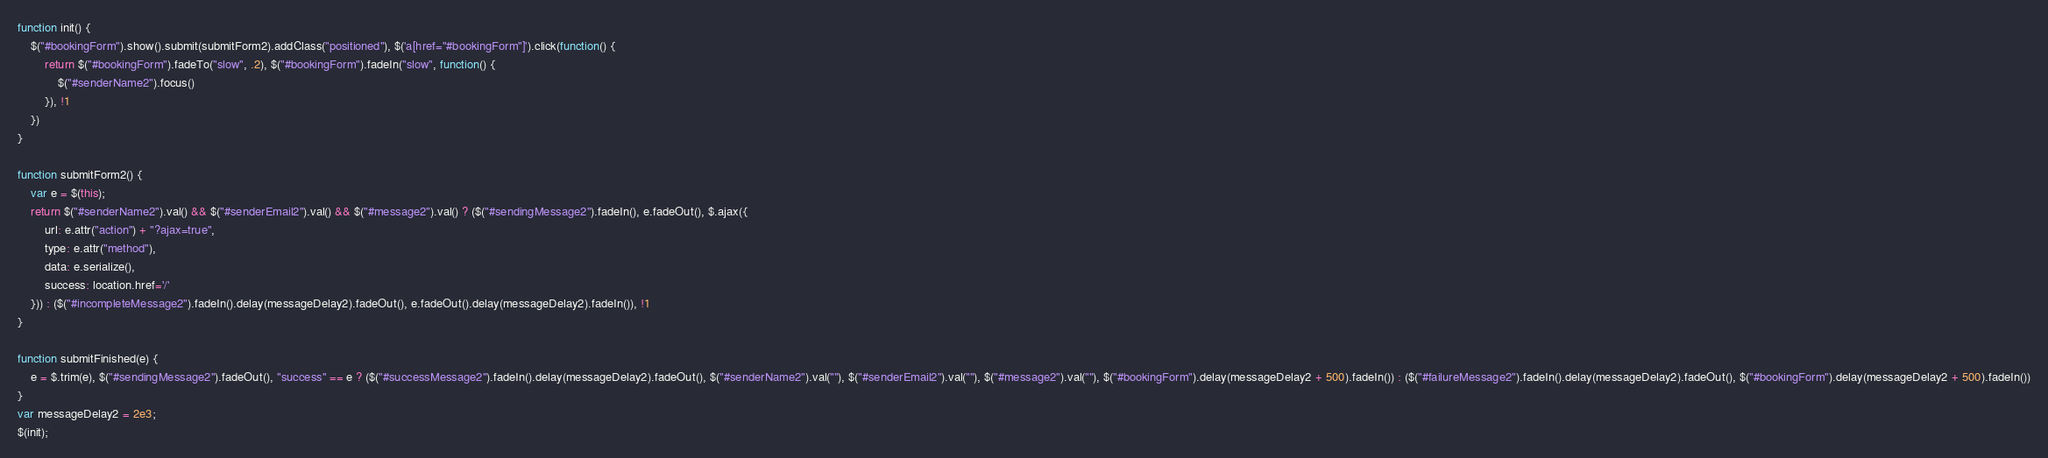<code> <loc_0><loc_0><loc_500><loc_500><_JavaScript_>function init() {
    $("#bookingForm").show().submit(submitForm2).addClass("positioned"), $('a[href="#bookingForm"]').click(function() {
        return $("#bookingForm").fadeTo("slow", .2), $("#bookingForm").fadeIn("slow", function() {
            $("#senderName2").focus()
        }), !1
    })
}

function submitForm2() {
    var e = $(this);
    return $("#senderName2").val() && $("#senderEmail2").val() && $("#message2").val() ? ($("#sendingMessage2").fadeIn(), e.fadeOut(), $.ajax({
        url: e.attr("action") + "?ajax=true",
        type: e.attr("method"),
        data: e.serialize(),
        success: location.href='/'
    })) : ($("#incompleteMessage2").fadeIn().delay(messageDelay2).fadeOut(), e.fadeOut().delay(messageDelay2).fadeIn()), !1
}

function submitFinished(e) {
    e = $.trim(e), $("#sendingMessage2").fadeOut(), "success" == e ? ($("#successMessage2").fadeIn().delay(messageDelay2).fadeOut(), $("#senderName2").val(""), $("#senderEmail2").val(""), $("#message2").val(""), $("#bookingForm").delay(messageDelay2 + 500).fadeIn()) : ($("#failureMessage2").fadeIn().delay(messageDelay2).fadeOut(), $("#bookingForm").delay(messageDelay2 + 500).fadeIn())
}
var messageDelay2 = 2e3;
$(init);</code> 